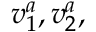<formula> <loc_0><loc_0><loc_500><loc_500>v _ { 1 } ^ { a } , v _ { 2 } ^ { a } ,</formula> 